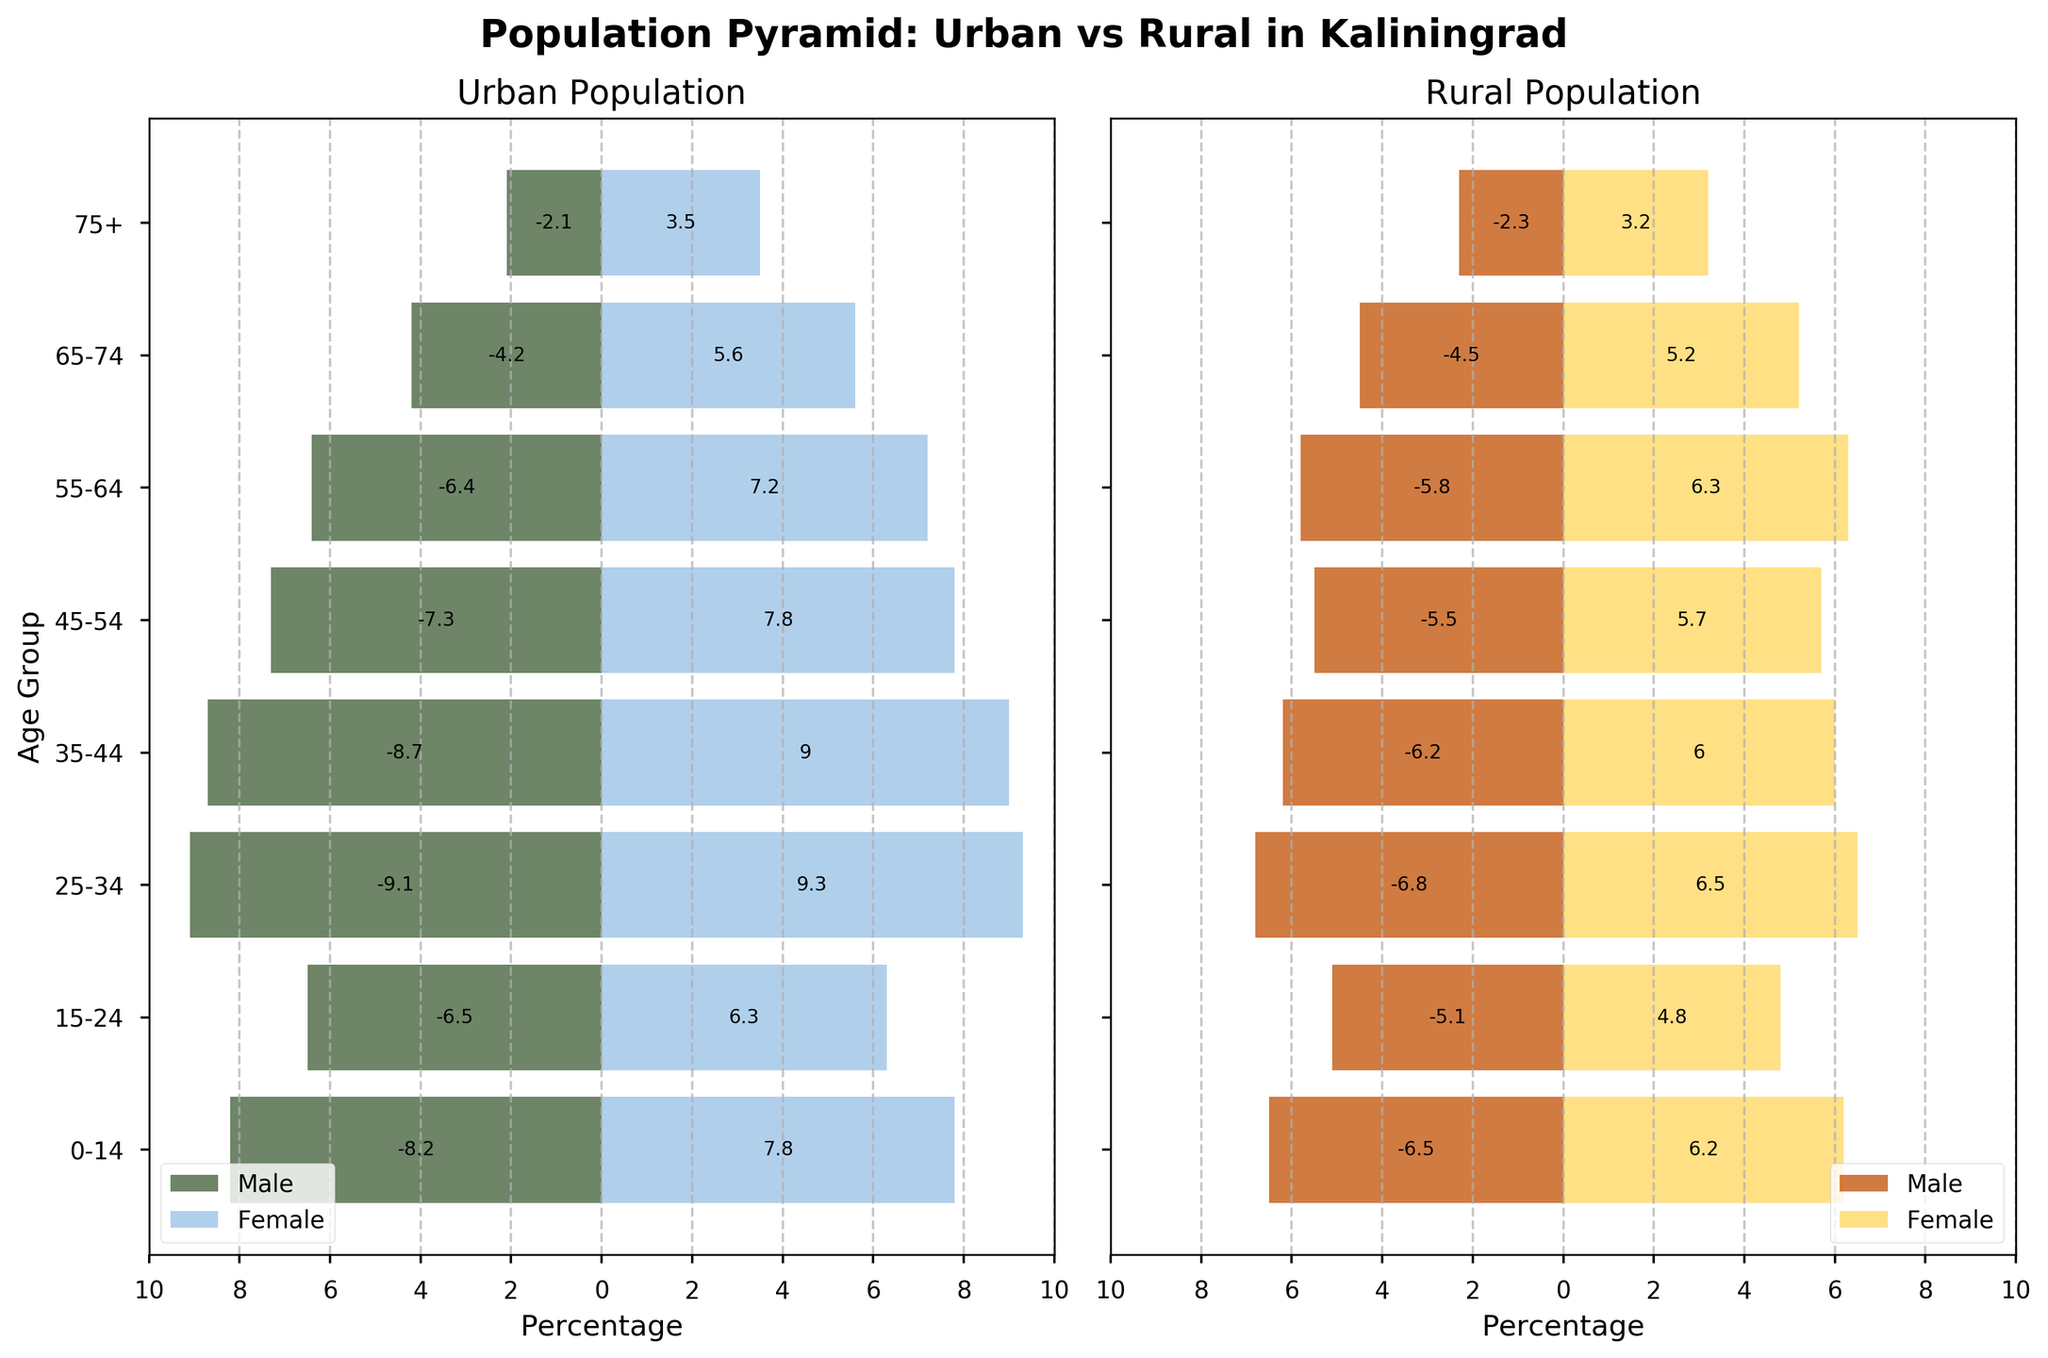What's the title of the plot? The title of the plot is mentioned at the top center of the figure. It reads "Population Pyramid: Urban vs Rural in Kaliningrad".
Answer: Population Pyramid: Urban vs Rural in Kaliningrad Which age group has the highest percentage of urban females? By looking at the urban population side, which is on the left, the age group with the highest percentage of urban females is the one where the bar extends the most to the right. This is the 25-34 age group with 9.3%.
Answer: 25-34 What is the percentage difference between urban males and rural males in the 0-14 age group? The percentage of urban males in the 0-14 age group is 8.2%, and the percentage of rural males in the same age group is 6.5%. The difference is calculated as 8.2% - 6.5% = 1.7%.
Answer: 1.7% Which population has a higher percentage of females in the 75+ age group, urban or rural? By comparing the length of the bars representing females in the 75+ age group on both the urban (left) and rural (right) populations, it's clear the rural population has a higher percentage. The values are 3.5% for urban and 3.2% for rural.
Answer: Urban How do the percentages of urban and rural males in the age group 35-44 compare? The urban males in the age group 35-44 make up 8.7%, whereas the rural males in the same age group make up 6.2%. Therefore, urban males have a higher percentage by 2.5%.
Answer: Urban males have a higher percentage by 2.5% In which age group do rural females outnumber urban females the most? Calculate the differences between the urban and rural percentages for females in each age group. The age group with the highest positive difference indicates where rural females outnumber urban females the most. The biggest difference is observed in the 0-14 age group, where the values are 6.2% (rural) and 7.8% (urban), indicating a 1.6% higher rural female percentage.
Answer: 0-14 What is the total percentage of the urban population (both males and females) in the 15-24 age group? The urban population percentages for males and females in the 15-24 age group are added together: 6.5% (males) + 6.3% (females) = 12.8%.
Answer: 12.8% Which age group shows the smallest gender disparity in the rural population? To determine the smallest gender disparity, check each age group for the smallest difference between male and female percentages in the rural population side of the plot. The smallest disparity is in the age group 55-64, with 5.8% males and 6.3% females, a difference of 0.5%.
Answer: 55-64 